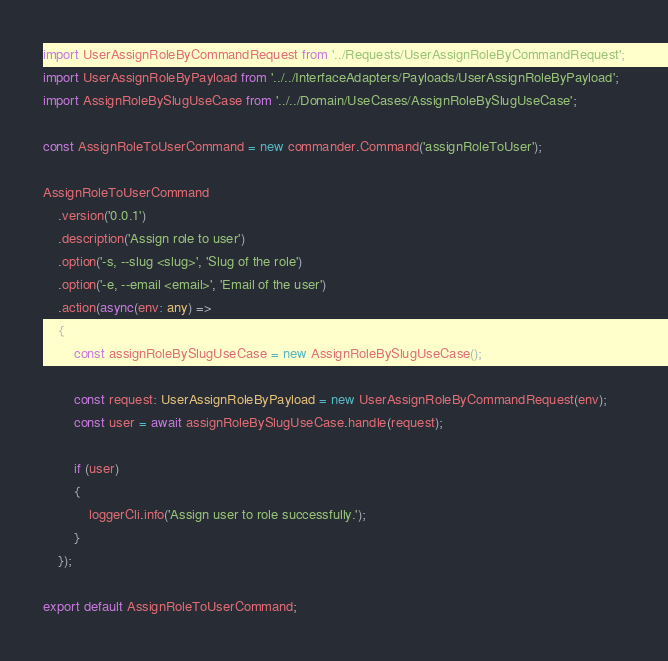Convert code to text. <code><loc_0><loc_0><loc_500><loc_500><_TypeScript_>import UserAssignRoleByCommandRequest from '../Requests/UserAssignRoleByCommandRequest';
import UserAssignRoleByPayload from '../../InterfaceAdapters/Payloads/UserAssignRoleByPayload';
import AssignRoleBySlugUseCase from '../../Domain/UseCases/AssignRoleBySlugUseCase';

const AssignRoleToUserCommand = new commander.Command('assignRoleToUser');

AssignRoleToUserCommand
    .version('0.0.1')
    .description('Assign role to user')
    .option('-s, --slug <slug>', 'Slug of the role')
    .option('-e, --email <email>', 'Email of the user')
    .action(async(env: any) =>
    {
        const assignRoleBySlugUseCase = new AssignRoleBySlugUseCase();

        const request: UserAssignRoleByPayload = new UserAssignRoleByCommandRequest(env);
        const user = await assignRoleBySlugUseCase.handle(request);

        if (user)
        {
            loggerCli.info('Assign user to role successfully.');
        }
    });

export default AssignRoleToUserCommand;
</code> 